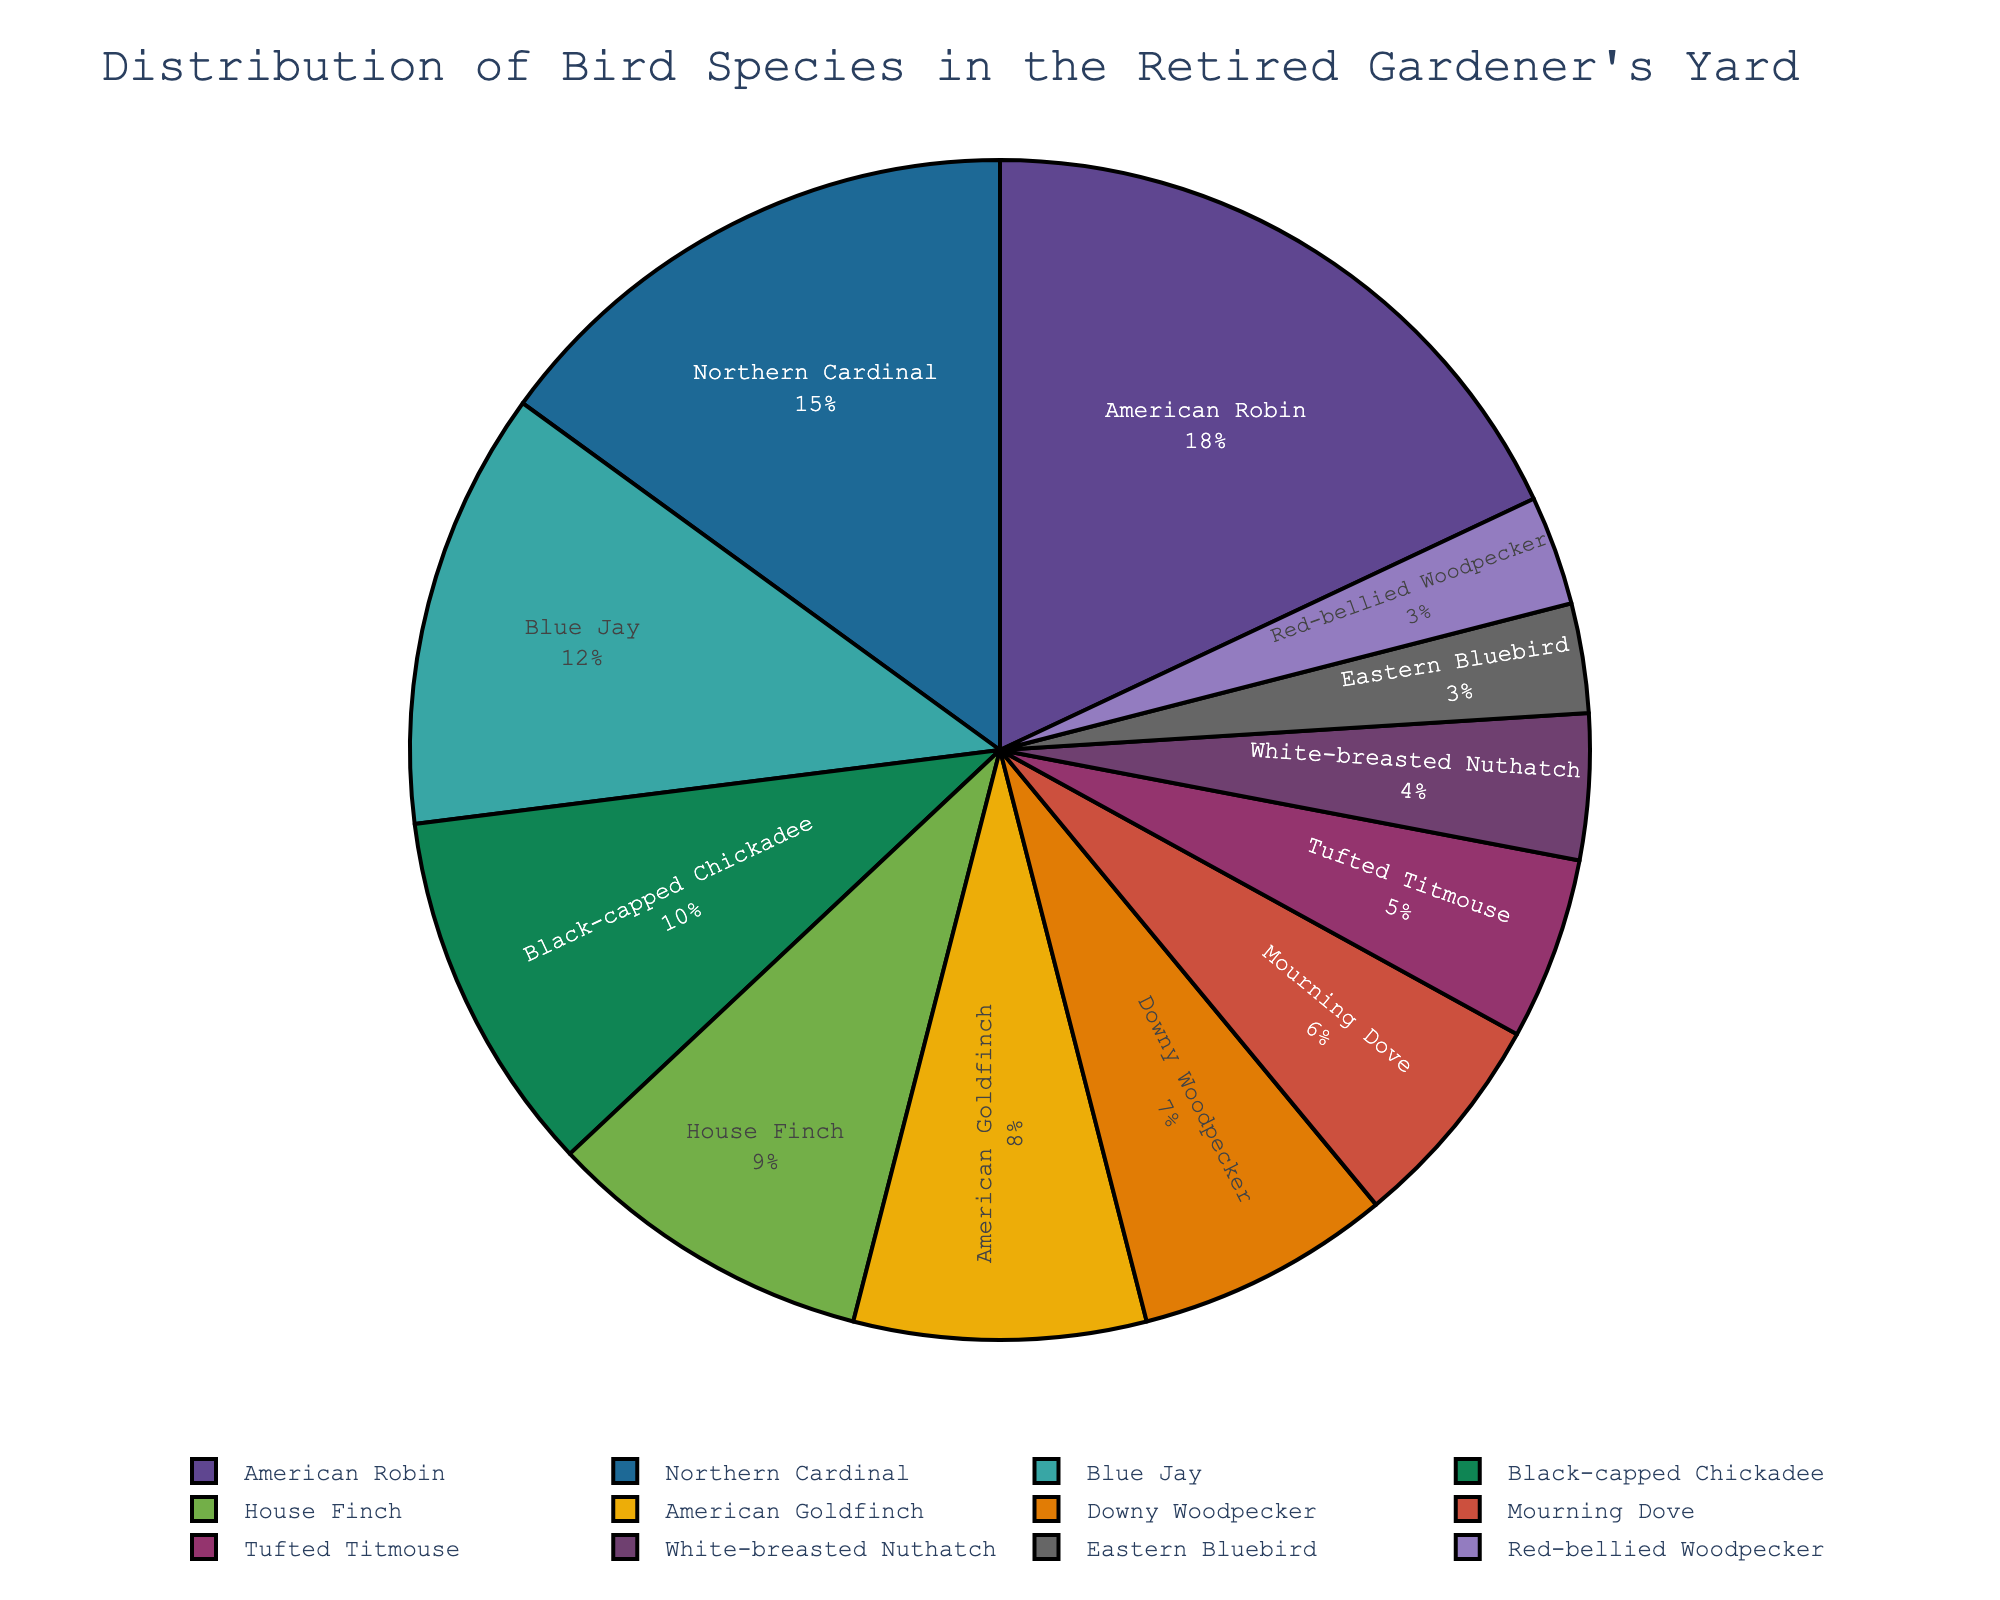Which bird species is observed the most? The American Robin slice is the largest in the pie chart, indicating it has the highest percentage.
Answer: American Robin What percentage of the birds observed are Northern Cardinals and Blue Jays combined? The pie chart shows Northern Cardinals at 15% and Blue Jays at 12%. Adding these values gives 15% + 12% = 27%.
Answer: 27% Which two bird species have an equal percentage of observations? The pie chart indicates that both Eastern Bluebirds and Red-bellied Woodpeckers each make up 3% of the observations.
Answer: Eastern Bluebird and Red-bellied Woodpecker How does the percentage of American Goldfinches compare to that of House Finches? The pie chart shows that American Goldfinches make up 8% and House Finches make up 9%. Since 8% < 9%, House Finches are observed more.
Answer: House Finches are observed more What is the total percentage of the top three most observed bird species? The top three species are American Robin (18%), Northern Cardinal (15%), and Blue Jay (12%). Adding these gives 18% + 15% + 12% = 45%.
Answer: 45% How many bird species make up less than 5% of the observations each? The pie chart indicates that White-breasted Nuthatch, Eastern Bluebird, and Red-bellied Woodpecker each make up 4%, 3%, and 3% respectively. That’s three bird species.
Answer: 3 Which species has a smaller observation percentage, the Tufted Titmouse or the Downy Woodpecker? The pie chart indicates that the Tufted Titmouse makes up 5%, while the Downy Woodpecker makes up 7%. Since 5% < 7%, Tufted Titmouse has a smaller observation percentage.
Answer: Tufted Titmouse Is the percentage of Black-capped Chickadees greater or less than that of House Finches and American Goldfinches combined? Black-capped Chickadees make up 10%. House Finches and American Goldfinches combined make up 9% + 8% = 17%. Since 10% < 17%, it is less.
Answer: Less What fraction of the total bird observations are Mourning Doves and Tufted Titmice when combined? The pie chart shows Mourning Doves at 6% and Tufted Titmice at 5%. Combined they make 6% + 5% = 11%. As a fraction, this is 11/100 or simplified, approximately 11/100.
Answer: 11/100 